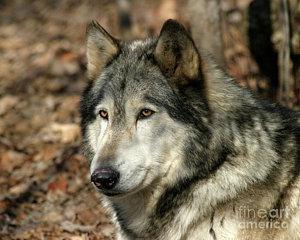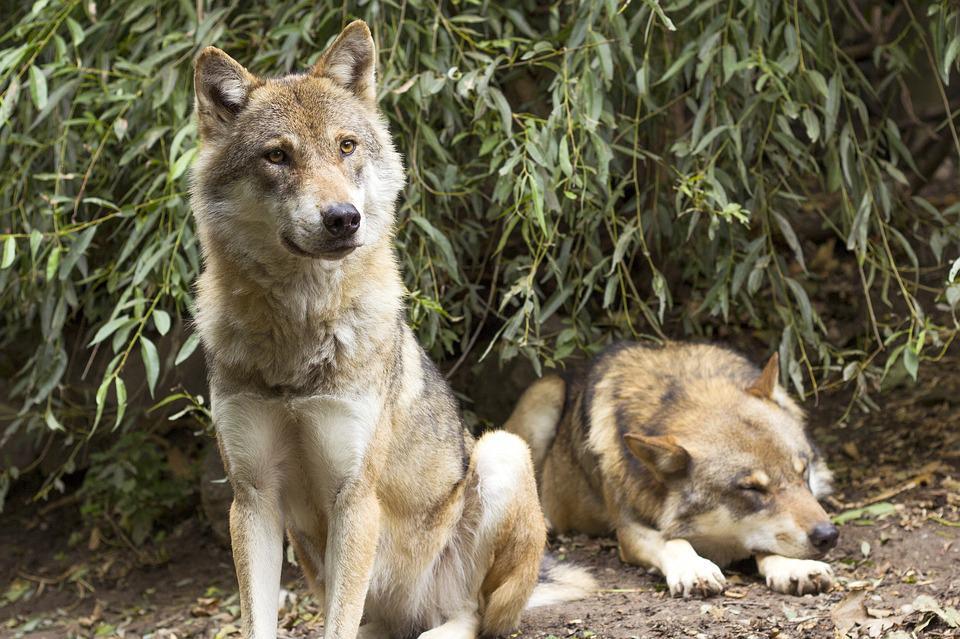The first image is the image on the left, the second image is the image on the right. Given the left and right images, does the statement "In total, no more than four wolves are visible." hold true? Answer yes or no. Yes. The first image is the image on the left, the second image is the image on the right. Given the left and right images, does the statement "There are at least five wolves." hold true? Answer yes or no. No. 